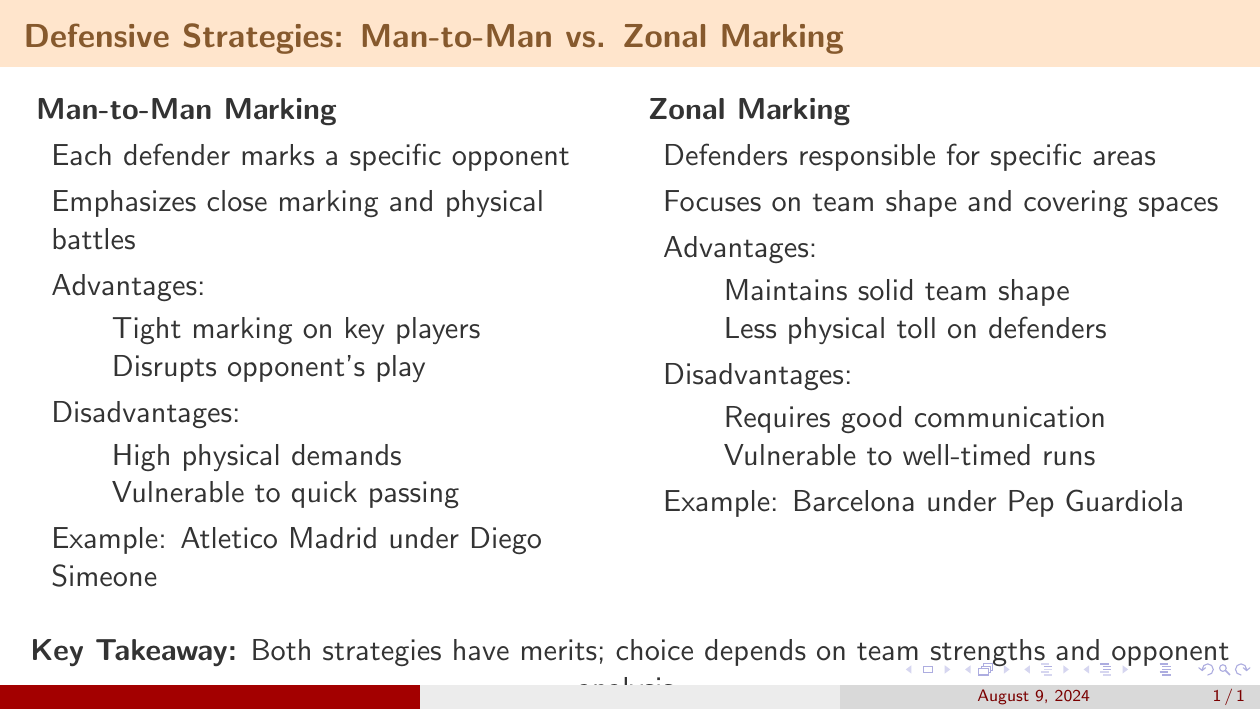What is the title of the slide? The title of the slide is the main heading presented at the top of the slide.
Answer: Defensive Strategies: Man-to-Man vs. Zonal Marking What is one advantage of Man-to-Man marking? The advantages are listed in a bullet point format under Man-to-Man marking section.
Answer: Tight marking on key players What is a disadvantage of Zonal marking? A disadvantage is provided among the bullet points under Zonal marking section.
Answer: Vulnerable to well-timed runs Which team example is associated with Man-to-Man marking? The example given for Man-to-Man marking is mentioned at the end of that section.
Answer: Atletico Madrid under Diego Simeone What is emphasized in Zonal marking? A key element of Zonal marking is highlighted in the initial definition of the strategy.
Answer: Team shape What is the key takeaway from the slide? The key takeaway summarizes the main point drawn from the comparison of marking strategies at the bottom of the slide.
Answer: Both strategies have merits; choice depends on team strengths and opponent analysis How many specific opponents does a defender mark in Man-to-Man marking? The description in the Man-to-Man marking section specifies how defenders operate in regards to their opponents.
Answer: Specific opponent What does Zonal marking focus on? The focus of Zonal marking is stated in its initial description.
Answer: Covering spaces Name an advantage of Zonal marking. An advantage is provided in bullet points under the Zonal marking explanation.
Answer: Maintains solid team shape 